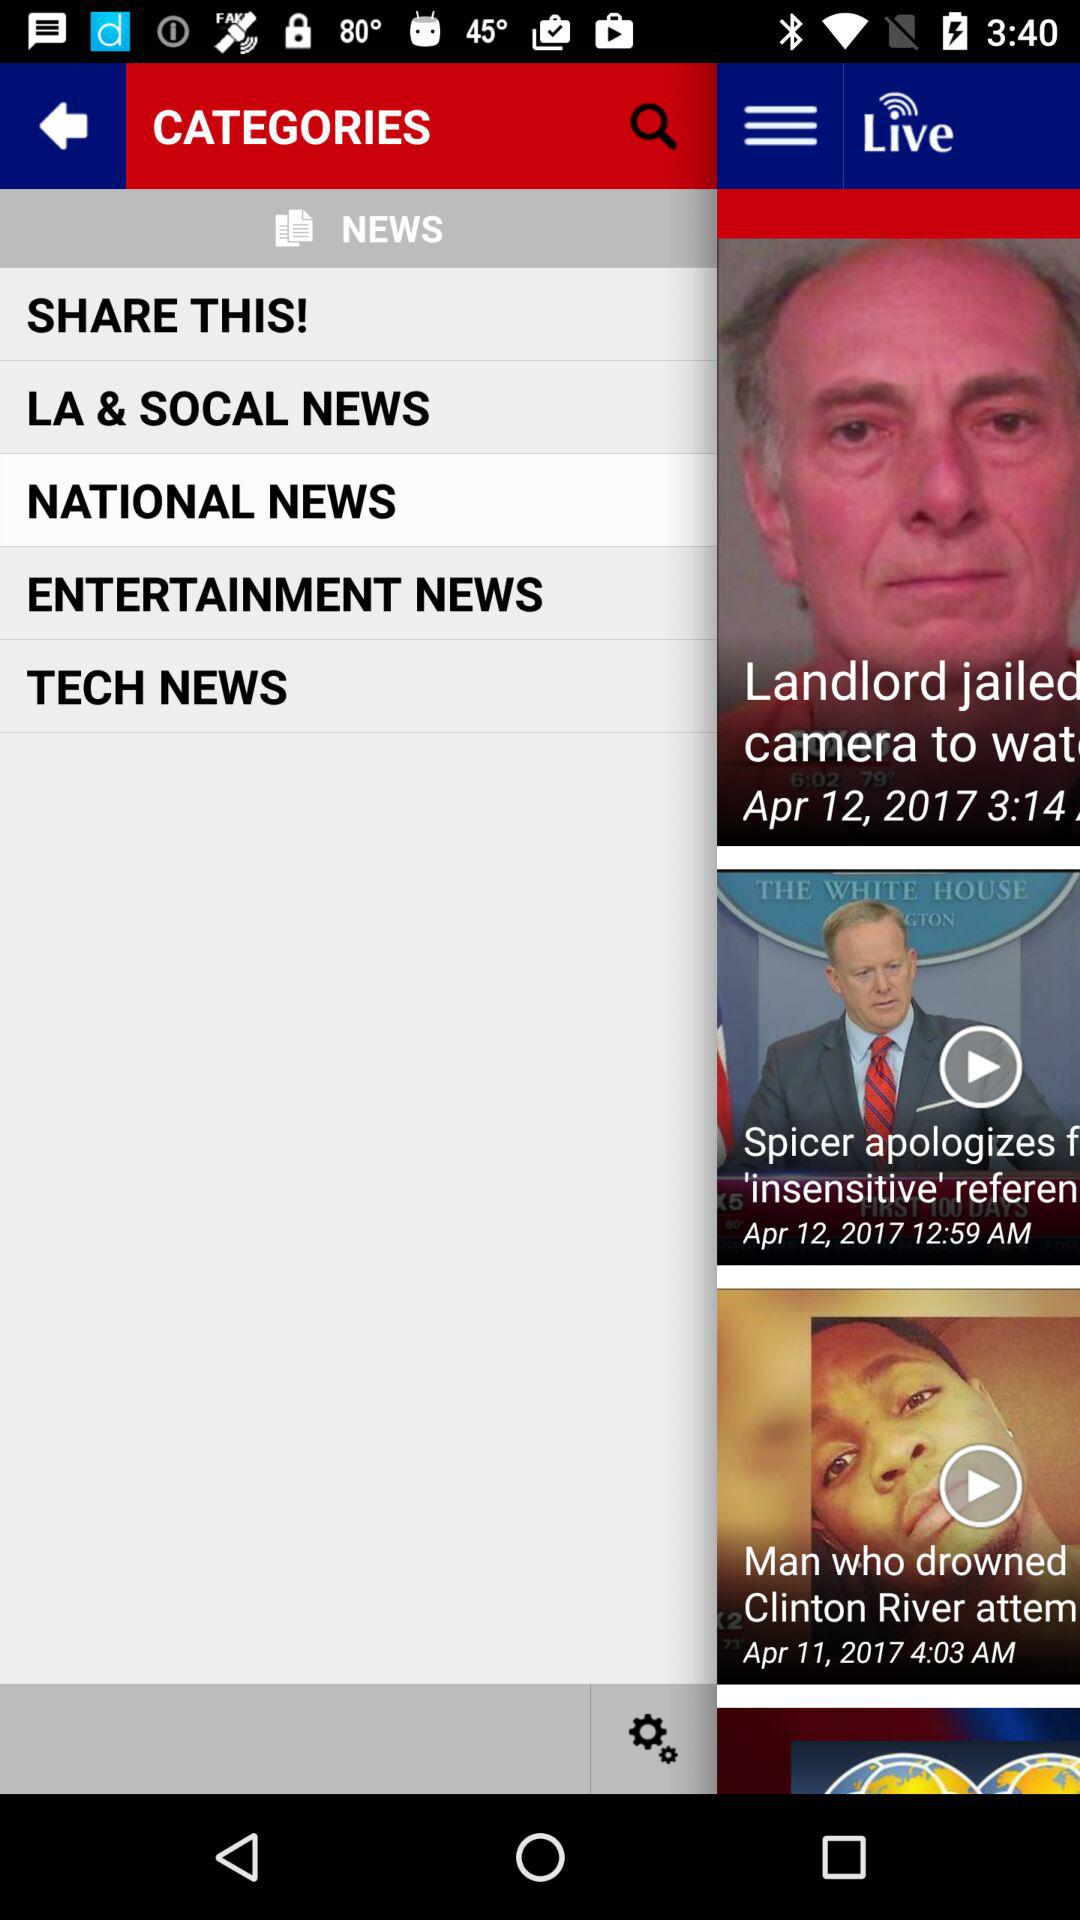What different types of news are available? The different types of news available are "LA & SOCAL NEWS", "NATIONAL NEWS", "ENTERTAINMENT NEWS" and "TECH NEWS". 